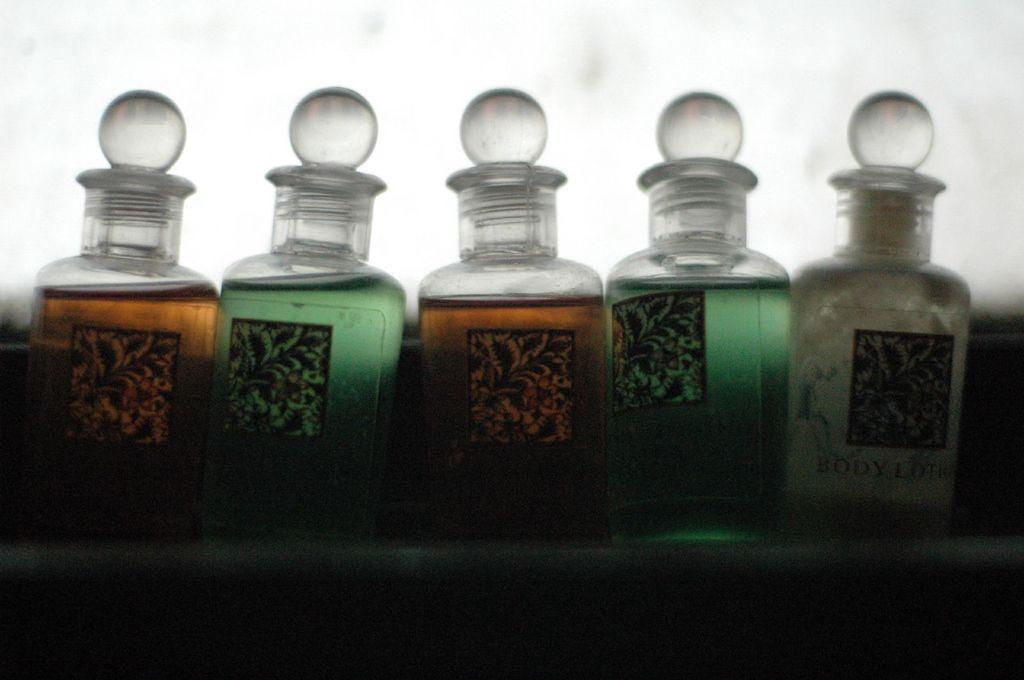<image>
Relay a brief, clear account of the picture shown. A row of bottles of whihch at least one says body lotion. 